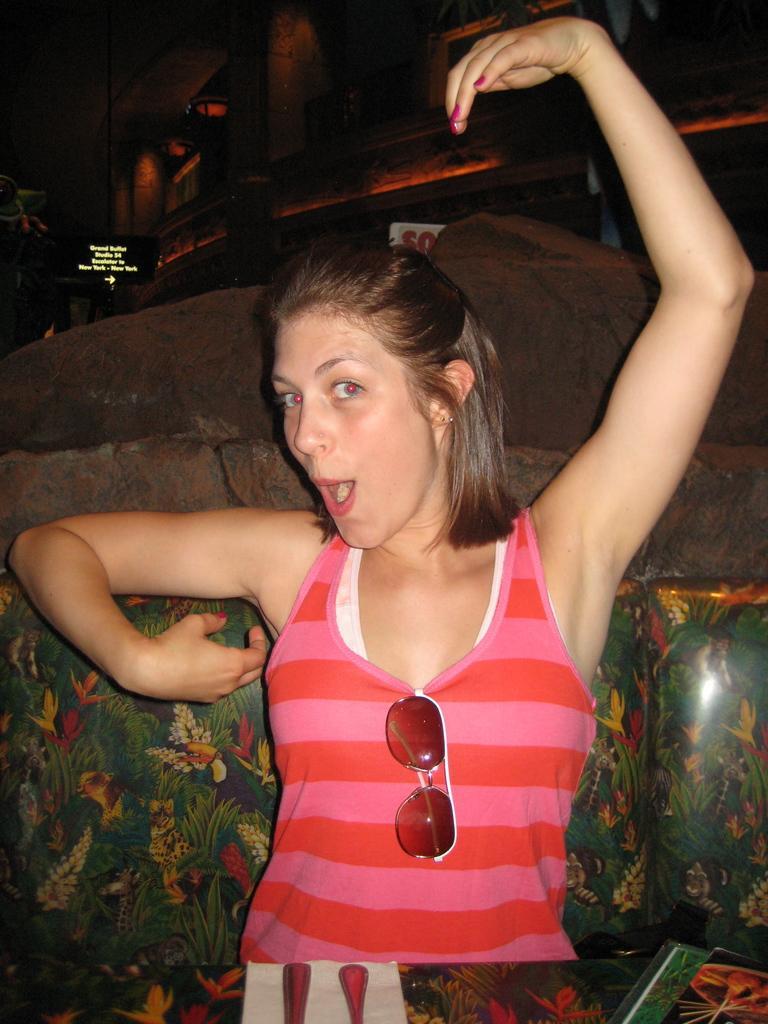Can you describe this image briefly? In this image we can see a woman. 